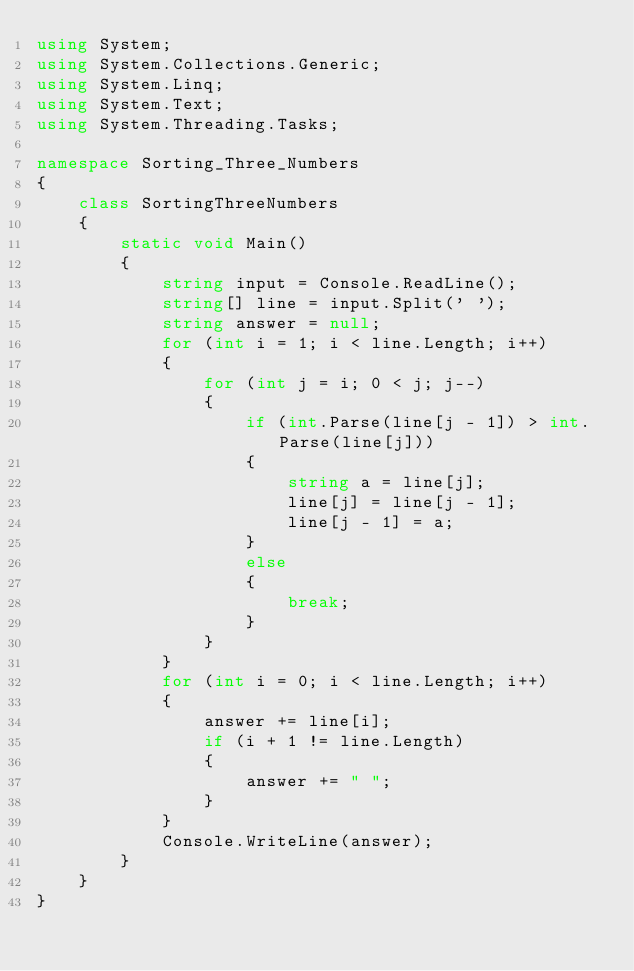<code> <loc_0><loc_0><loc_500><loc_500><_C#_>using System;
using System.Collections.Generic;
using System.Linq;
using System.Text;
using System.Threading.Tasks;

namespace Sorting_Three_Numbers
{
    class SortingThreeNumbers
    {
        static void Main()
        {
            string input = Console.ReadLine();
            string[] line = input.Split(' ');
            string answer = null;
            for (int i = 1; i < line.Length; i++)
            {
                for (int j = i; 0 < j; j--)
                {
                    if (int.Parse(line[j - 1]) > int.Parse(line[j]))
                    {
                        string a = line[j];
                        line[j] = line[j - 1];
                        line[j - 1] = a;
                    }
                    else
                    {
                        break;
                    }
                }
            }
            for (int i = 0; i < line.Length; i++)
            {
                answer += line[i];
                if (i + 1 != line.Length)
                {
                    answer += " ";
                }
            }
            Console.WriteLine(answer);
        }
    }
}

</code> 